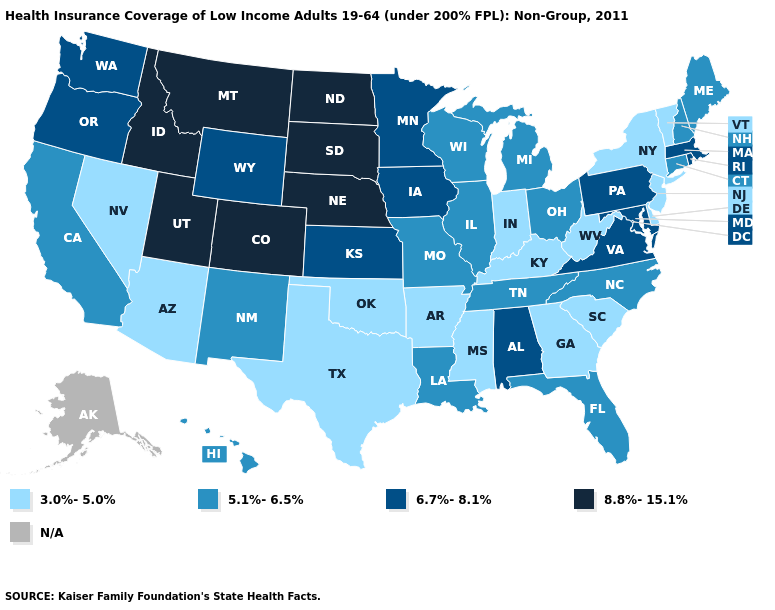Does Mississippi have the lowest value in the USA?
Keep it brief. Yes. Does the map have missing data?
Be succinct. Yes. Does the map have missing data?
Give a very brief answer. Yes. Which states hav the highest value in the MidWest?
Be succinct. Nebraska, North Dakota, South Dakota. Does New Jersey have the lowest value in the Northeast?
Answer briefly. Yes. Is the legend a continuous bar?
Answer briefly. No. Which states hav the highest value in the MidWest?
Short answer required. Nebraska, North Dakota, South Dakota. Does New Jersey have the lowest value in the USA?
Answer briefly. Yes. Which states hav the highest value in the West?
Short answer required. Colorado, Idaho, Montana, Utah. Does Indiana have the lowest value in the MidWest?
Answer briefly. Yes. Name the states that have a value in the range 8.8%-15.1%?
Give a very brief answer. Colorado, Idaho, Montana, Nebraska, North Dakota, South Dakota, Utah. What is the value of Michigan?
Answer briefly. 5.1%-6.5%. What is the value of Iowa?
Quick response, please. 6.7%-8.1%. What is the value of New Mexico?
Give a very brief answer. 5.1%-6.5%. What is the lowest value in the USA?
Short answer required. 3.0%-5.0%. 